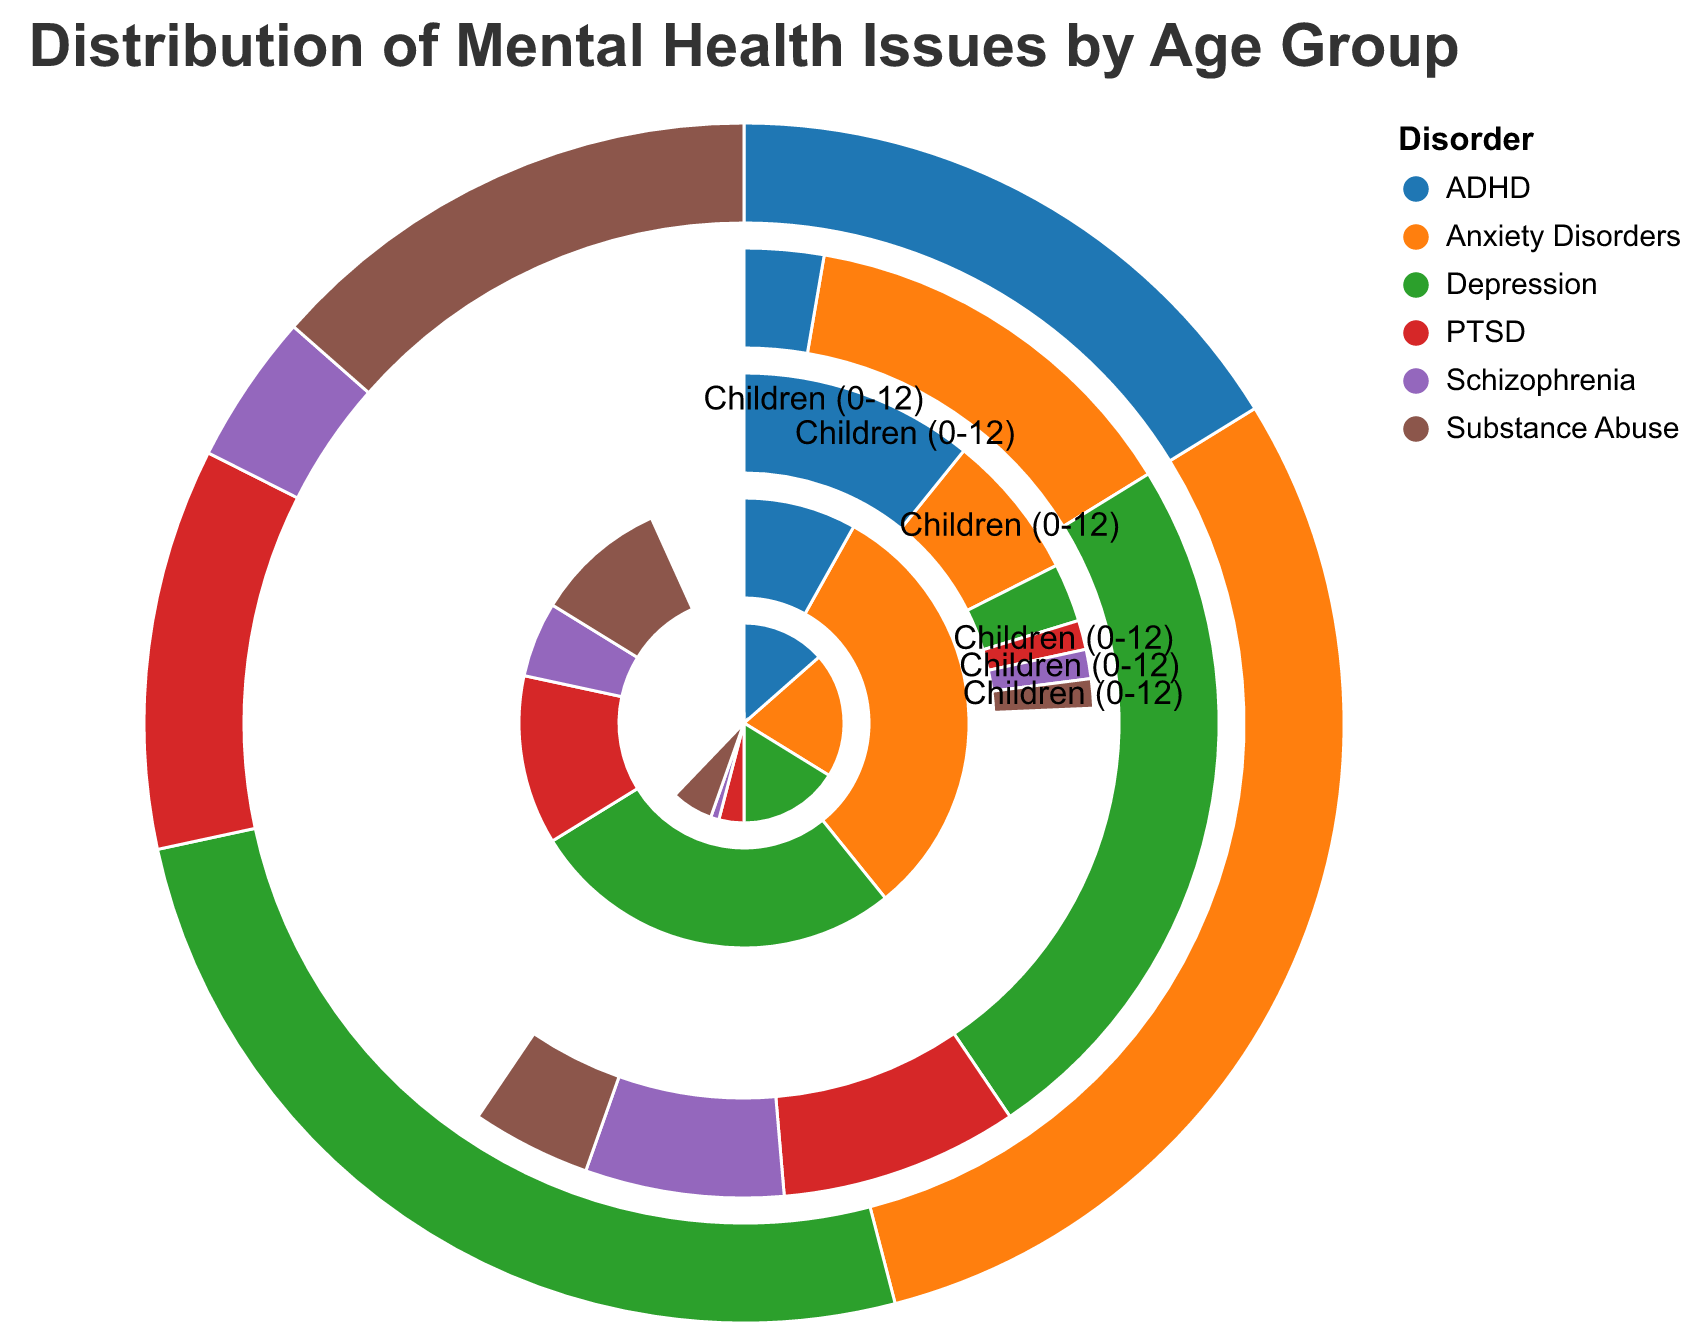What is the title of the figure? The title of the figure is typically located at the top and provides a summary of what the visual represents. Here, it is written as "Distribution of Mental Health Issues by Age Group."
Answer: Distribution of Mental Health Issues by Age Group Which age group has the highest value for Anxiety Disorders? By examining each section of the polar chart labeled for "Anxiety Disorders," we can see that the age group "Adults (25-64)" has the largest arc for this disorder.
Answer: Adults (25-64) Which disorder is most prominent among Young Adults (18-24)? To determine this, look at the different segments for "Young Adults (18-24)" and identify which has the largest value. In this case, "Anxiety Disorders" is the most prominent.
Answer: Anxiety Disorders What is the sum of Depression cases for Adolescents (13-17) and Seniors (65+)? Sum the values for Depression in these two age groups: Adolescents (13-17) have 12 cases, and Seniors (65+) have 18 cases. Adding them together, 12 + 18 = 30.
Answer: 30 Which age group has the least number of Substance Abuse cases? By comparing the arcs representing "Substance Abuse" for all age groups, "Children (0-12)" and "Seniors (65+)" both show equal but least values, and we can conclude that "Children (0-12)" has 1 case which is least covered in the Polar Chart.
Answer: Children (0-12) How does the number of PTSD cases in Young Adults (18-24) compare with Adults (25-64)? Look at the segments for PTSD in "Young Adults (18-24)" and "Adults (25-64)" to compare them. Young Adults (18-24) have 8 cases, while Adults (25-64) have 9 cases. Thus, Adults (25-64) have a slightly higher number of PTSD cases.
Answer: Adults (25-64) have more Which disorder has the smallest representation across all age groups? To find this, we should identify the smallest total value for any disorder across all age groups. Summing up each disorder from all age groups, Schizophrenia has the smallest total of 14 across all age groups.
Answer: Schizophrenia In which age group is the difference between Depression and ADHD the smallest? Calculate the differences in value between Depression and ADHD for each age group: For Children (0-12), Adolescents (13-17), Young Adults (18-24), Adults (25-64), and Seniors (65+), the respective differences are 6, 2, 7, 14, and 16. The smallest difference is 2, found in Adolescents (13-17).
Answer: Adolescents (13-17) What proportion of the total cases in Seniors (65+) are related to Schizophrenia? Sum the total cases for Seniors (65+): 10 (Anxiety) + 18 (Depression) + 2 (ADHD) + 6 (PTSD) + 5 (Schizophrenia) + 3 (Substance Abuse) = 44. The proportion for Schizophrenia is 5/44. To find the proportion, divide 5 by 44, which gives approximately 0.114 or 11.4%.
Answer: 11.4% Which two age groups have the highest combined total of ADHD cases, and what is this total? Sum the ADHD cases for all age groups: Children (0-12) = 8, Adolescents (13-17) = 10, Young Adults (18-24) = 12, Adults (25-64) = 6, and Seniors (65+) = 2. The two highest are Young Adults (18-24) with 12 cases and Adolescents (13-17) with 10 cases. Their combined total is 12 + 10 = 22.
Answer: Young Adults (18-24) and Adolescents (13-17), total = 22 